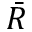Convert formula to latex. <formula><loc_0><loc_0><loc_500><loc_500>\bar { R }</formula> 